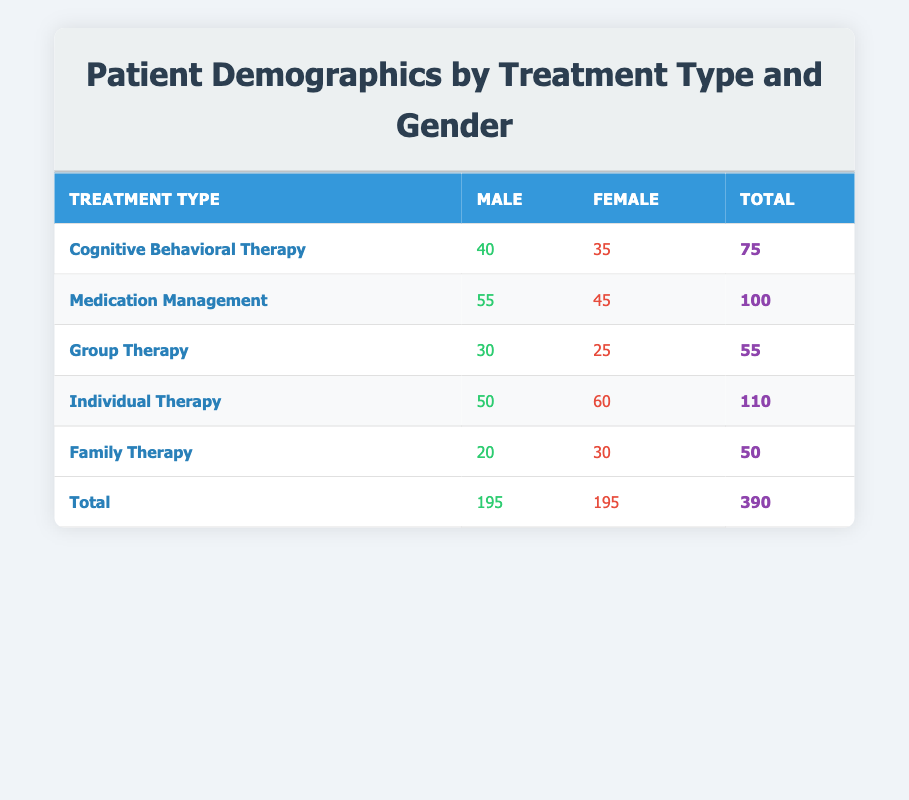What is the count of males receiving Individual Therapy? The table shows that the count of males receiving Individual Therapy is listed under the corresponding row. Specifically, for Individual Therapy, the male count is 50.
Answer: 50 What is the total number of patients receiving Family Therapy? To find the total number of patients receiving Family Therapy, we can look at the corresponding row and sum the counts of males and females: 20 (male) + 30 (female) = 50.
Answer: 50 Is the number of females receiving Cognitive Behavioral Therapy greater than the number of males receiving the same treatment? We compare the counts in the Cognitive Behavioral Therapy row, where females have a count of 35 and males have a count of 40. Since 35 is not greater than 40, the statement is false.
Answer: No What is the difference in counts between males and females for Group Therapy? We can find this by looking at the Group Therapy row, where males have a count of 30 and females have a count of 25. The difference is calculated as 30 (male) - 25 (female) = 5.
Answer: 5 What is the total number of male and female patients across all treatment types? To find this, we look at the total counts for males and females from the last row in the table. The total count for males is 195 and for females is also 195. We can add both totals: 195 + 195 = 390.
Answer: 390 What is the average count of female patients across all treatment types? To calculate the average count of female patients, we first sum the female counts: 35 (Cognitive Behavioral Therapy) + 45 (Medication Management) + 25 (Group Therapy) + 60 (Individual Therapy) + 30 (Family Therapy) = 195. Then, we divide this total by the number of treatment types (5): 195 / 5 = 39.
Answer: 39 Is the number of males receiving Medication Management higher than the combined total of males in the other treatments? We first note the male count for Medication Management, which is 55. Then we sum the counts of males in the other treatments: 40 (Cognitive Behavioral Therapy) + 30 (Group Therapy) + 50 (Individual Therapy) + 20 (Family Therapy) = 140. Since 55 is not greater than 140, the answer is no.
Answer: No Which treatment type has the highest total count of patients? By observing the total column in the table, we see that the treatment type with the highest total is Individual Therapy with a count of 110.
Answer: Individual Therapy What percentage of total patients are male? The total number of patients is 390, with males totaling 195. To find the percentage of male patients, we calculate (195 / 390) * 100, which equals 50%.
Answer: 50% 